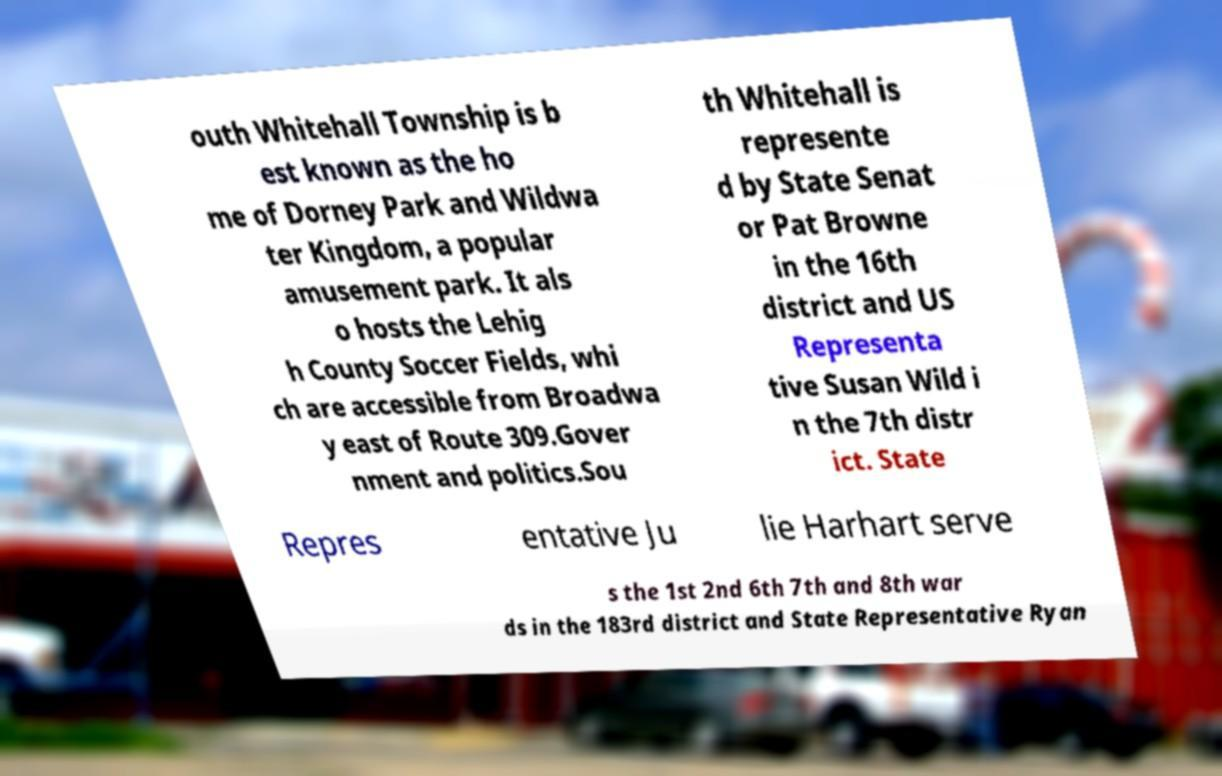Can you accurately transcribe the text from the provided image for me? outh Whitehall Township is b est known as the ho me of Dorney Park and Wildwa ter Kingdom, a popular amusement park. It als o hosts the Lehig h County Soccer Fields, whi ch are accessible from Broadwa y east of Route 309.Gover nment and politics.Sou th Whitehall is represente d by State Senat or Pat Browne in the 16th district and US Representa tive Susan Wild i n the 7th distr ict. State Repres entative Ju lie Harhart serve s the 1st 2nd 6th 7th and 8th war ds in the 183rd district and State Representative Ryan 